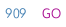<code> <loc_0><loc_0><loc_500><loc_500><_SQL_>GO</code> 